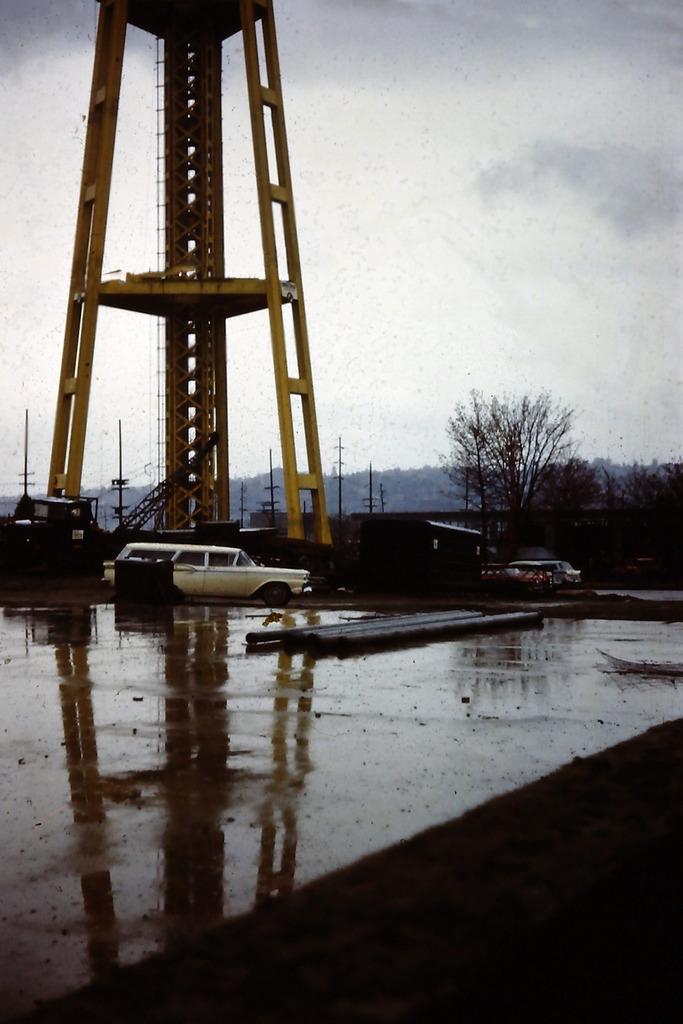Can you describe this image briefly? This picture is clicked outside the city. At the bottom of the picture, we see the road. We see vehicles are moving on the road. Behind that, we see a yellow color tower. There are trees in the background. There are electric poles and hills in the background. At the top of the picture, we see the sky. 